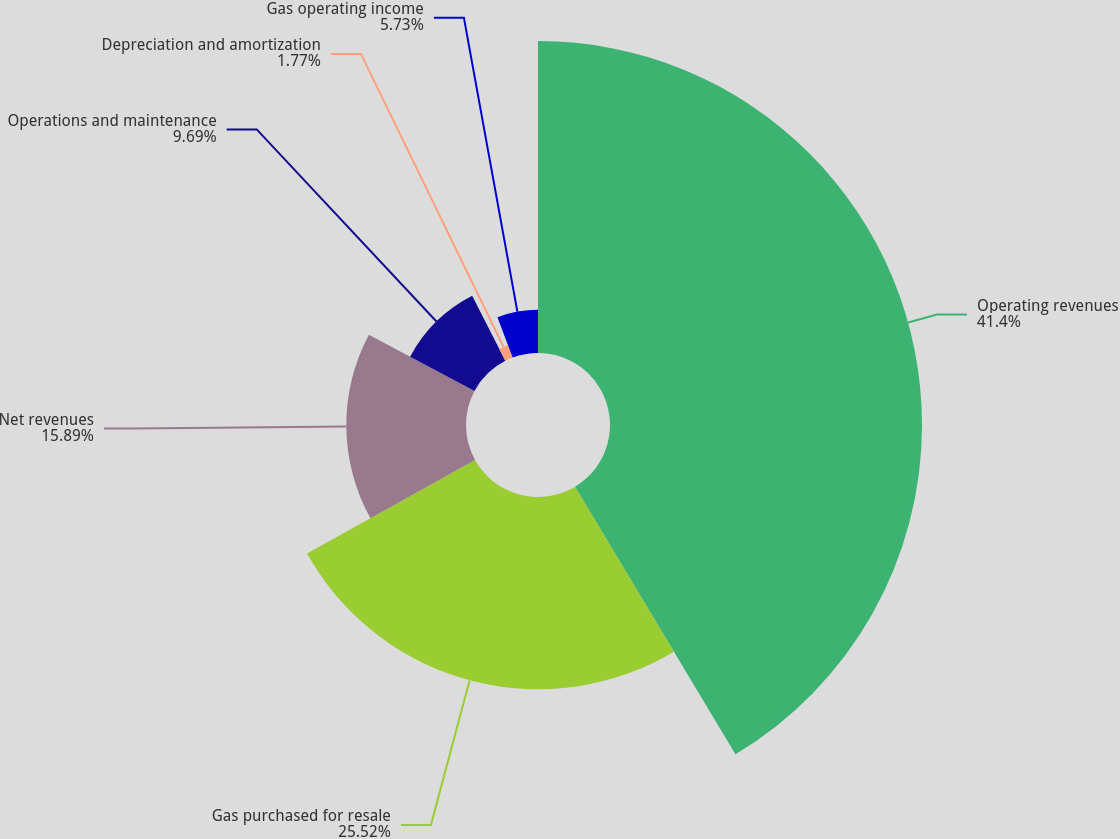Convert chart to OTSL. <chart><loc_0><loc_0><loc_500><loc_500><pie_chart><fcel>Operating revenues<fcel>Gas purchased for resale<fcel>Net revenues<fcel>Operations and maintenance<fcel>Depreciation and amortization<fcel>Gas operating income<nl><fcel>41.41%<fcel>25.52%<fcel>15.89%<fcel>9.69%<fcel>1.77%<fcel>5.73%<nl></chart> 